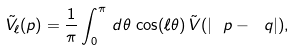<formula> <loc_0><loc_0><loc_500><loc_500>\tilde { V } _ { \ell } ( p ) = \frac { 1 } { \pi } \int _ { 0 } ^ { \pi } \, d \theta \, \cos ( \ell \theta ) \, \tilde { V } ( | \ p - \ q | ) ,</formula> 